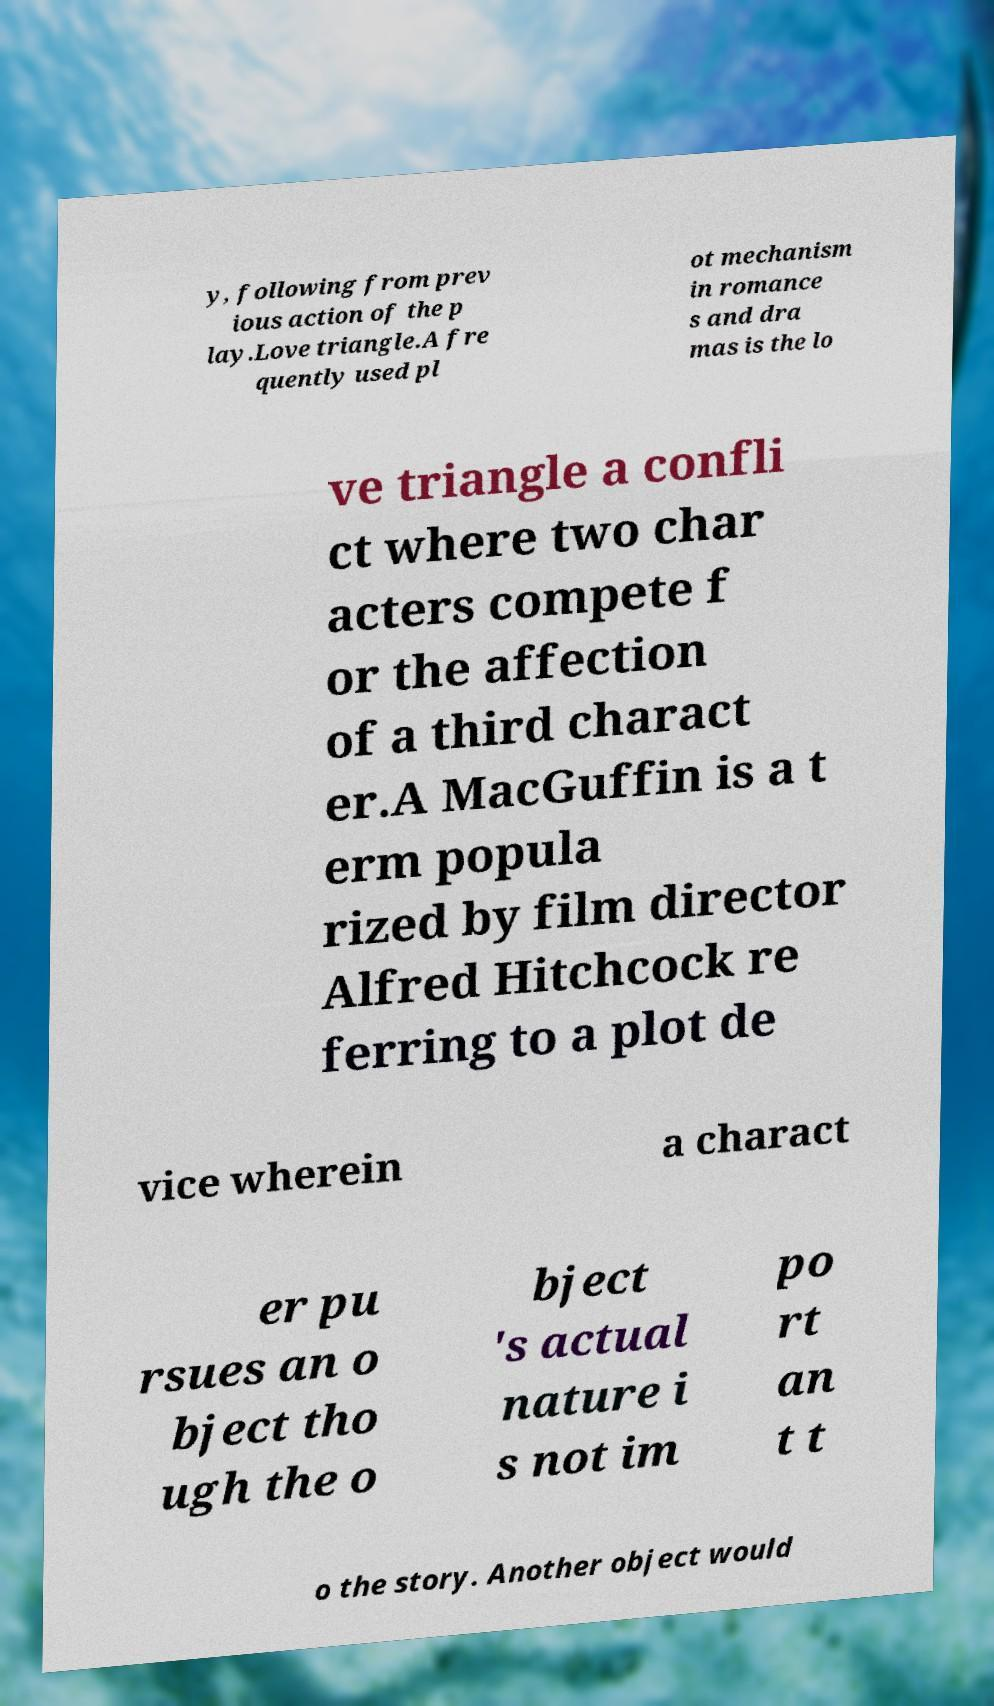Can you read and provide the text displayed in the image?This photo seems to have some interesting text. Can you extract and type it out for me? y, following from prev ious action of the p lay.Love triangle.A fre quently used pl ot mechanism in romance s and dra mas is the lo ve triangle a confli ct where two char acters compete f or the affection of a third charact er.A MacGuffin is a t erm popula rized by film director Alfred Hitchcock re ferring to a plot de vice wherein a charact er pu rsues an o bject tho ugh the o bject 's actual nature i s not im po rt an t t o the story. Another object would 